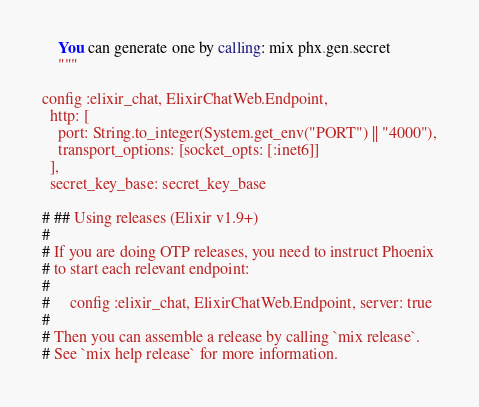Convert code to text. <code><loc_0><loc_0><loc_500><loc_500><_Elixir_>    You can generate one by calling: mix phx.gen.secret
    """

config :elixir_chat, ElixirChatWeb.Endpoint,
  http: [
    port: String.to_integer(System.get_env("PORT") || "4000"),
    transport_options: [socket_opts: [:inet6]]
  ],
  secret_key_base: secret_key_base

# ## Using releases (Elixir v1.9+)
#
# If you are doing OTP releases, you need to instruct Phoenix
# to start each relevant endpoint:
#
#     config :elixir_chat, ElixirChatWeb.Endpoint, server: true
#
# Then you can assemble a release by calling `mix release`.
# See `mix help release` for more information.
</code> 